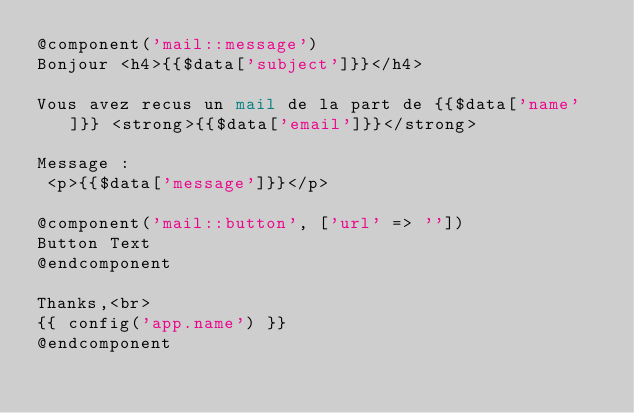Convert code to text. <code><loc_0><loc_0><loc_500><loc_500><_PHP_>@component('mail::message')
Bonjour <h4>{{$data['subject']}}</h4>

Vous avez recus un mail de la part de {{$data['name']}} <strong>{{$data['email']}}</strong>

Message :
 <p>{{$data['message']}}</p>

@component('mail::button', ['url' => ''])
Button Text
@endcomponent

Thanks,<br>
{{ config('app.name') }}
@endcomponent
</code> 